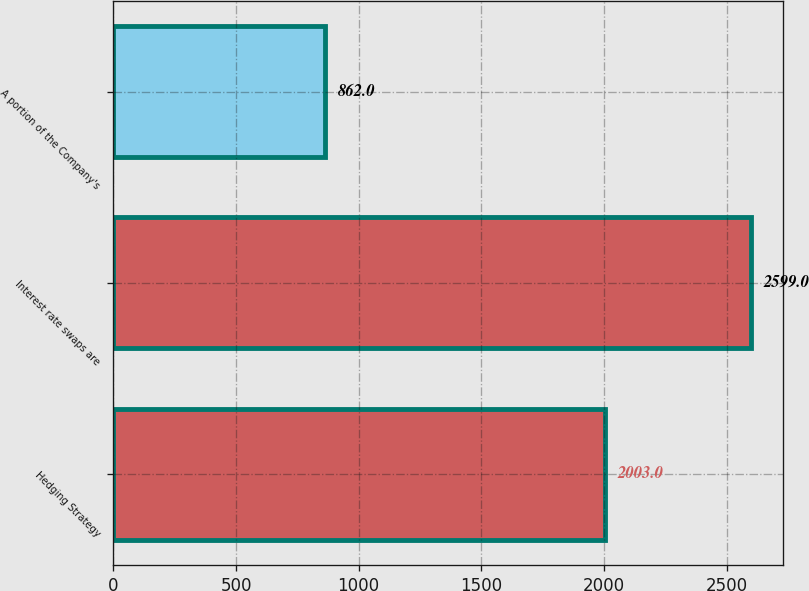Convert chart to OTSL. <chart><loc_0><loc_0><loc_500><loc_500><bar_chart><fcel>Hedging Strategy<fcel>Interest rate swaps are<fcel>A portion of the Company's<nl><fcel>2003<fcel>2599<fcel>862<nl></chart> 